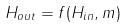Convert formula to latex. <formula><loc_0><loc_0><loc_500><loc_500>H _ { o u t } = f ( H _ { i n } , m )</formula> 